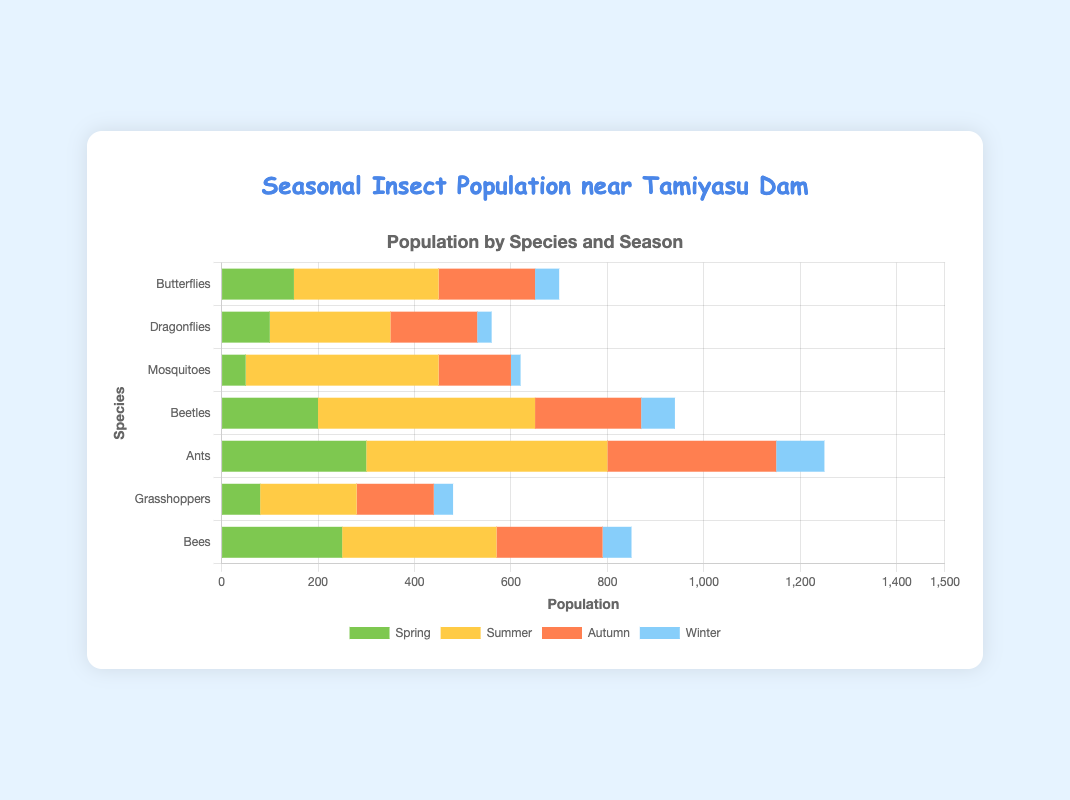What is the total population of beetles across all seasons? Sum the populations of beetles in each season: Spring (200) + Summer (450) + Autumn (220) + Winter (70) = 940
Answer: 940 Which species has the highest population in summer? Compare the summer populations for all species: Butterflies (300), Dragonflies (250), Mosquitoes (400), Beetles (450), Ants (500), Grasshoppers (200), Bees (320). Ants have the highest population.
Answer: Ants Which season has the lowest population of mosquitoes? Compare the mosquito populations for each season: Spring (50), Summer (400), Autumn (150), Winter (20). The lowest population is in Winter.
Answer: Winter What is the average population of bees across all seasons? Sum the populations of bees in each season: Spring (250) + Summer (320) + Autumn (220) + Winter (60) = 850. Divide by the number of seasons (4). 850 / 4 = 212.5
Answer: 212.5 Are ants more populous in spring or autumn? Compare the ant populations: Spring (300) vs Autumn (350). Ants are more populous in Autumn.
Answer: Autumn Which species experienced the smallest change in population between spring and summer? Calculate the difference for each species: Butterflies (300-150 = 150), Dragonflies (250-100 = 150), Mosquitoes (400-50 = 350), Beetles (450-200 = 250), Ants (500-300 = 200), Grasshoppers (200-80 = 120), Bees (320-250 = 70). Bees experienced the smallest change (70).
Answer: Bees How does the winter population of dragonflies compare to the summer population of grasshoppers? Compare populations: Dragonflies in Winter (30) vs Grasshoppers in Summer (200). Grasshoppers in summer have a higher population.
Answer: Grasshoppers in summer What is the combined population of insects in autumn for all species? Sum the populations of all species in autumn: Butterflies (200) + Dragonflies (180) + Mosquitoes (150) + Beetles (220) + Ants (350) + Grasshoppers (160) + Bees (220) = 1480
Answer: 1480 Which species’ population decreases the most from summer to winter? Calculate the difference for each species from summer to winter: Butterflies (300-50 = 250), Dragonflies (250-30 = 220), Mosquitoes (400-20 = 380), Beetles (450-70 = 380), Ants (500-100 = 400), Grasshoppers (200-40 = 160), Bees (320-60 = 260). Ants population decreases the most by 400.
Answer: Ants 